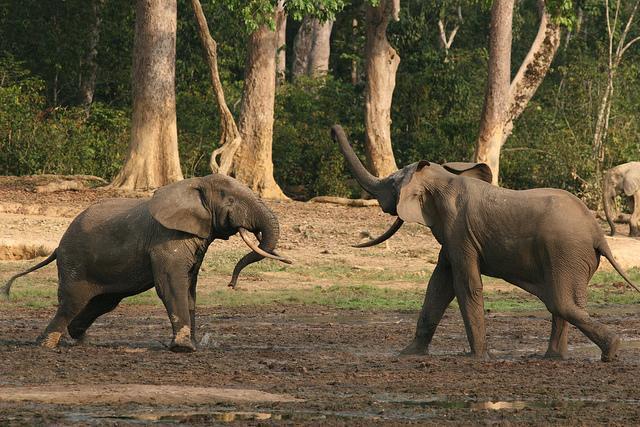How many elephants are the main focus of the picture?
Give a very brief answer. 2. How many elephants are visible?
Give a very brief answer. 2. 